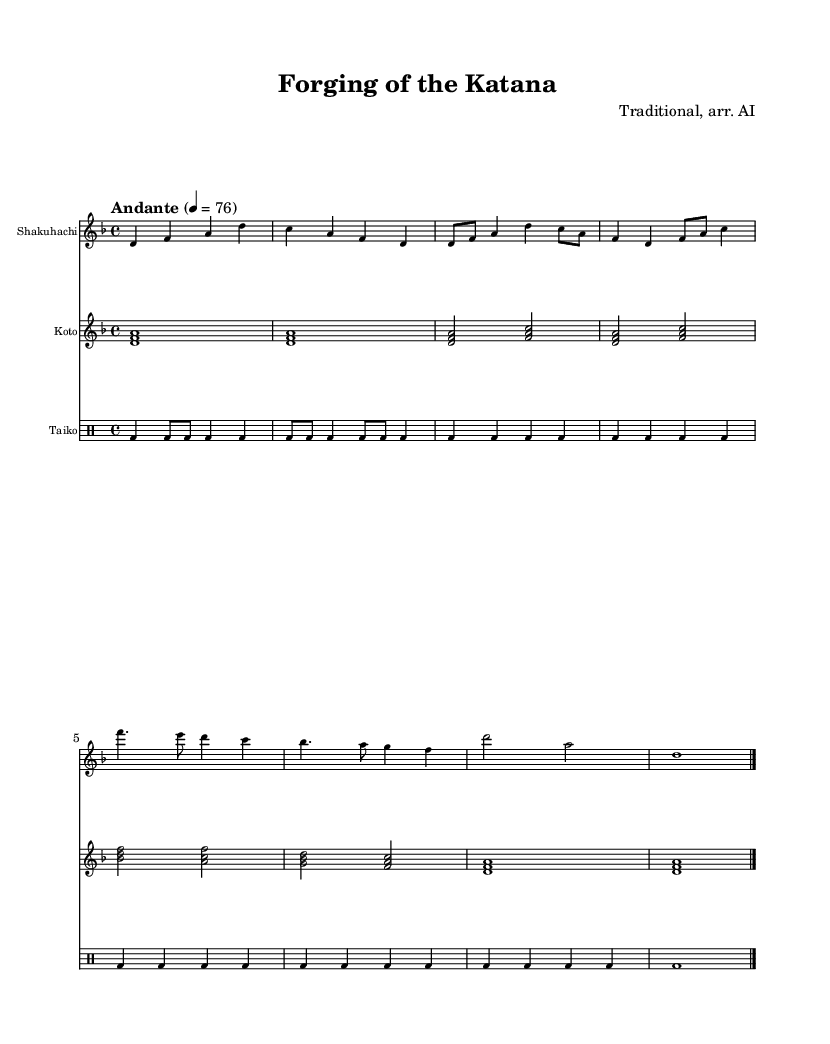What is the key signature of this music? The key signature is indicated at the beginning of the score, where it shows a flat symbol in the key of D minor. This key has one flat, which is B flat.
Answer: D minor What is the time signature? The time signature can be found at the beginning of the score, showing 4/4, which means there are four beats in a measure with a quarter note receiving one beat.
Answer: 4/4 What is the tempo marking? The tempo marking is stated in Italian at the beginning of the score, specifying "Andante," which means a moderate pace. Additionally, it is indicated as 4 = 76, which gives a specific speed for the beats.
Answer: Andante How many measures does the shakuhachi part have? The shakuhachi part is written out in the score, and by counting the grouped sections divided by bar lines, there are a total of 8 measures in the shakuhachi part.
Answer: 8 Which instrument has a drum staff? The presence of the section labeled as "DrumStaff" indicates that this staff is dedicated to drums, specifically the taiko in this piece. This is distinguishable from the other staves which represent melodic instruments.
Answer: Taiko What is the note value of the first two notes in the koto part? In the koto part, the first two notes are written as a chord and are both whole notes. The duration is indicated as the note is sustained throughout the measure without division.
Answer: Whole note 